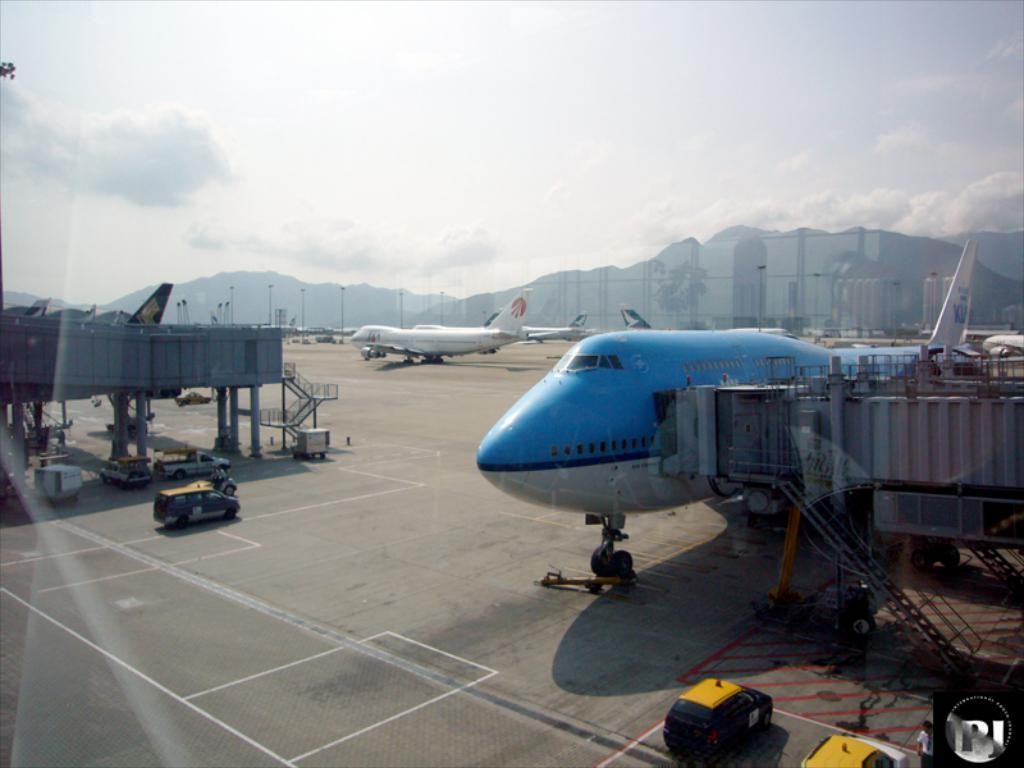What type of vehicles are present on the road in the image? There are aeroplanes on the road in the image. What else can be seen on the road besides the aeroplanes? There are no other vehicles visible on the road in the image. What can be seen in the background of the image? There are mountains in the background of the image. What is visible at the top of the image? There are clouds at the top of the image. Can you describe the clouds in the image? Yes, there are clouds visible in the image. What type of bag is being carried by the clouds in the image? There are no bags present in the image, and the clouds are not carrying anything. How does the feeling of the aeroplanes on the road affect the weather in the image? The image does not depict any feelings or emotions of the aeroplanes, and the weather is represented by the clouds and mountains, not the vehicles on the road. 